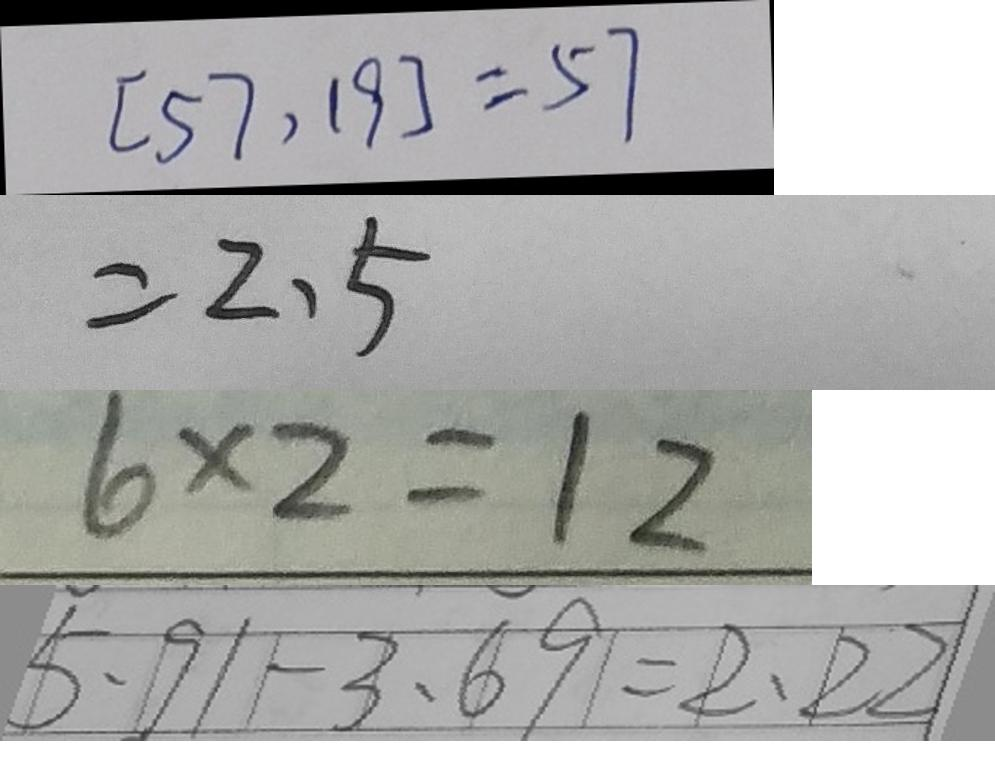<formula> <loc_0><loc_0><loc_500><loc_500>[ 5 7 , 1 9 ] = 5 7 
 = 2 . 5 
 6 \times 2 = 1 2 
 5 . 9 1 - 3 . 6 9 = 2 . 2 2</formula> 